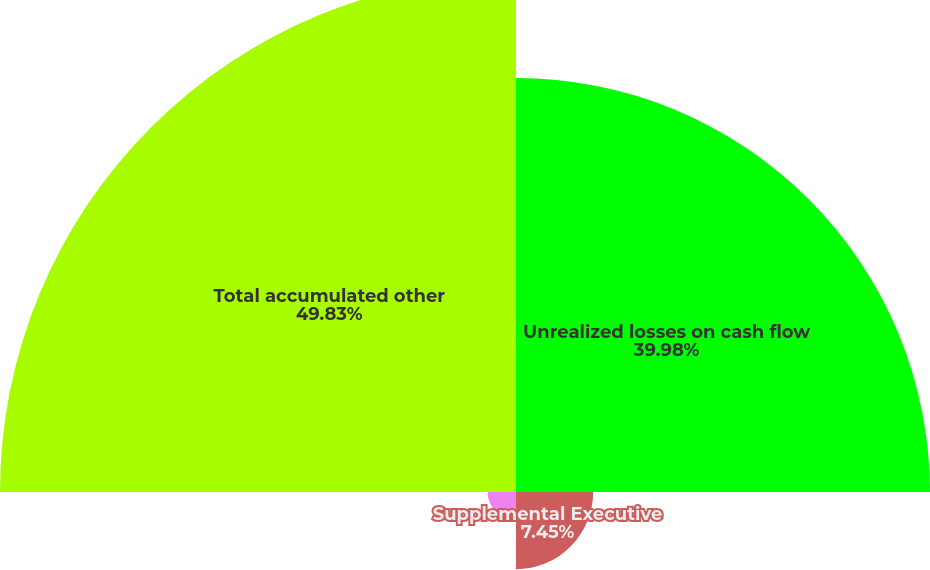<chart> <loc_0><loc_0><loc_500><loc_500><pie_chart><fcel>Unrealized losses on cash flow<fcel>Supplemental Executive<fcel>Cumulative foreign currency<fcel>Total accumulated other<nl><fcel>39.98%<fcel>7.45%<fcel>2.74%<fcel>49.83%<nl></chart> 